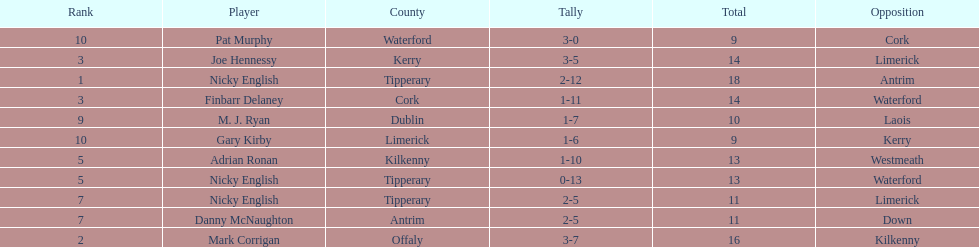Which player ranked the most? Nicky English. 